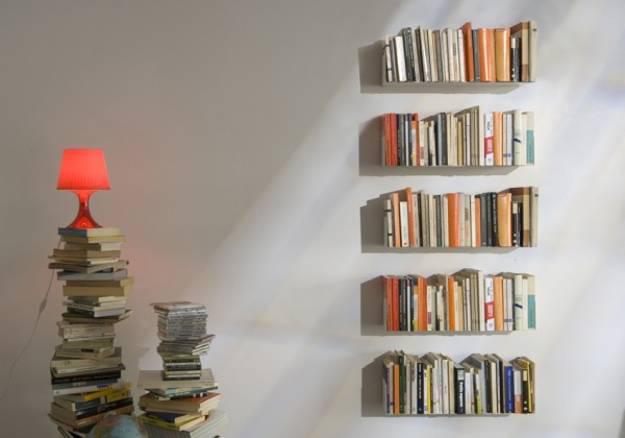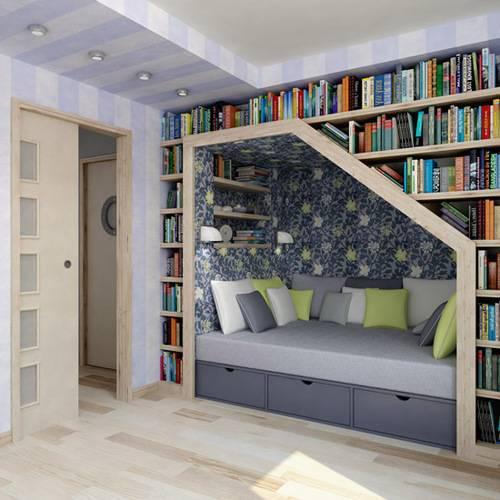The first image is the image on the left, the second image is the image on the right. Examine the images to the left and right. Is the description "There is at least one plant in the pair of images." accurate? Answer yes or no. No. The first image is the image on the left, the second image is the image on the right. Assess this claim about the two images: "Both images show some type of floating white bookshelves that mount to the wall.". Correct or not? Answer yes or no. No. 